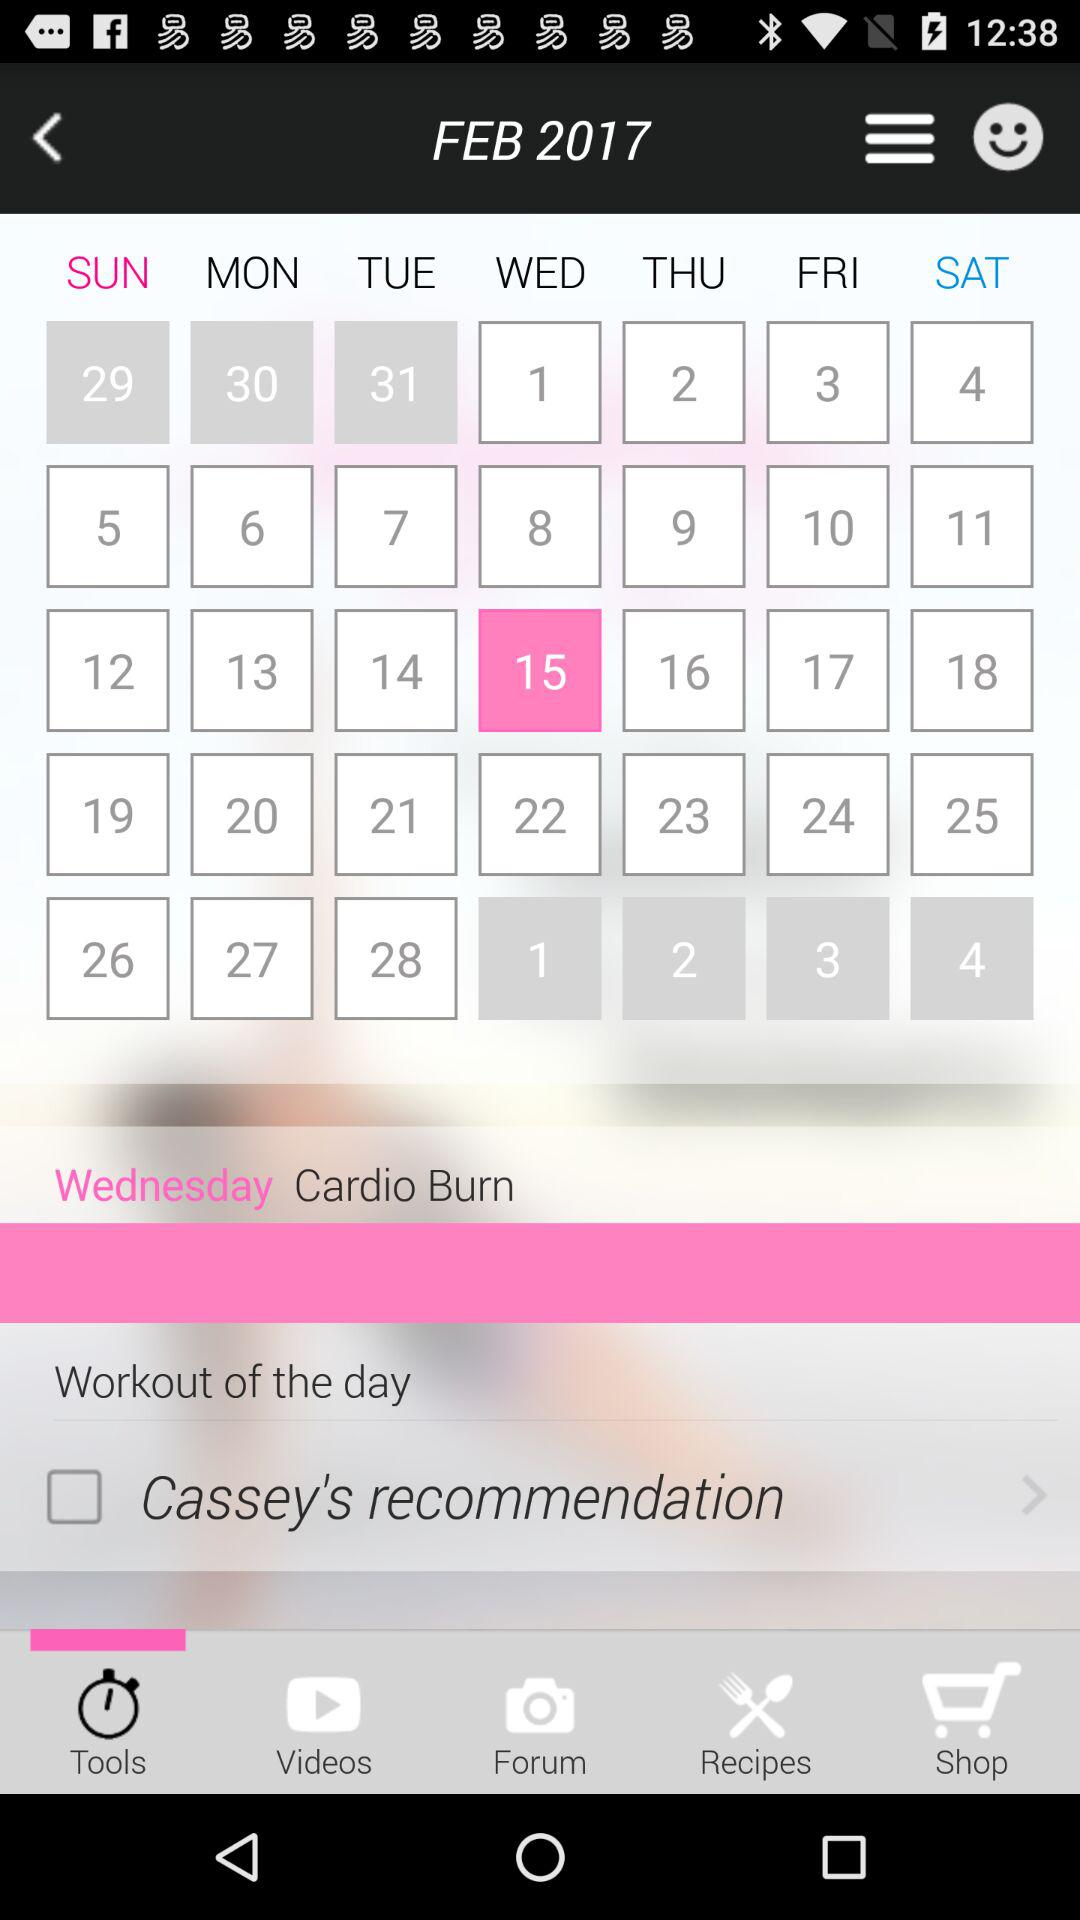What is the name of the exercise? The name of the exercise is Cardio Burn. 